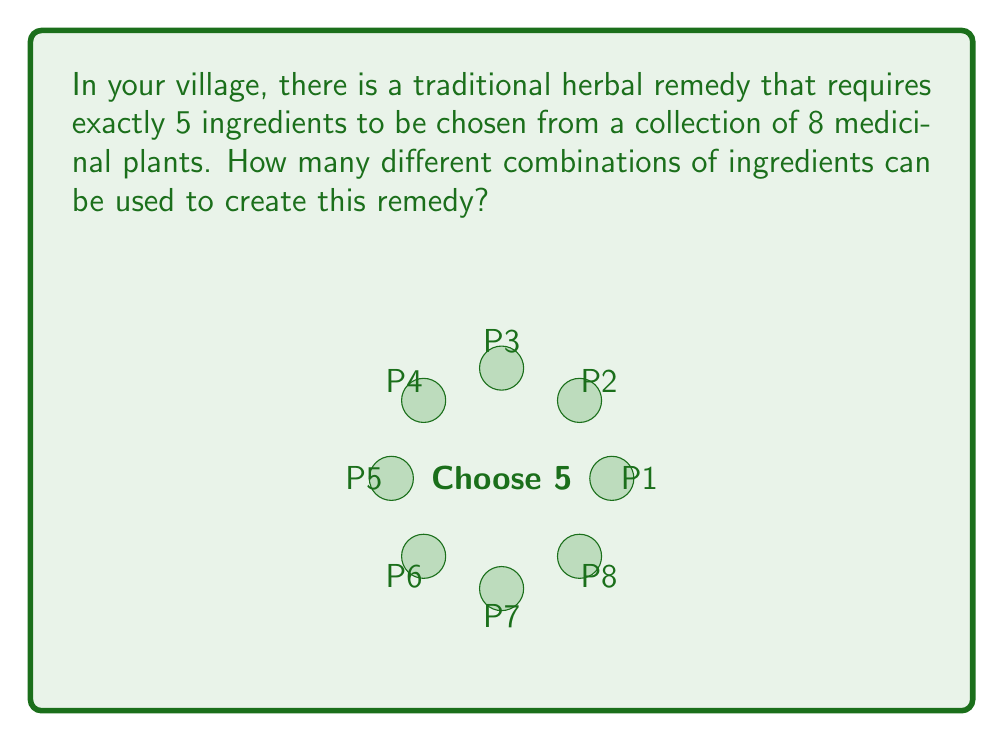Provide a solution to this math problem. To solve this problem, we need to use the combination formula. We are selecting 5 items from a set of 8, where the order doesn't matter (since we're just creating a mixture).

The formula for combinations is:

$$C(n,r) = \binom{n}{r} = \frac{n!}{r!(n-r)!}$$

Where:
$n$ is the total number of items to choose from (8 in this case)
$r$ is the number of items being chosen (5 in this case)

Let's substitute our values:

$$C(8,5) = \binom{8}{5} = \frac{8!}{5!(8-5)!} = \frac{8!}{5!3!}$$

Now, let's calculate this step-by-step:

1) $8! = 8 \times 7 \times 6 \times 5 \times 4 \times 3 \times 2 \times 1 = 40,320$
2) $5! = 5 \times 4 \times 3 \times 2 \times 1 = 120$
3) $3! = 3 \times 2 \times 1 = 6$

Substituting these values:

$$\frac{8!}{5!3!} = \frac{40,320}{120 \times 6} = \frac{40,320}{720} = 56$$

Therefore, there are 56 different combinations of 5 ingredients that can be chosen from the 8 available medicinal plants.
Answer: 56 